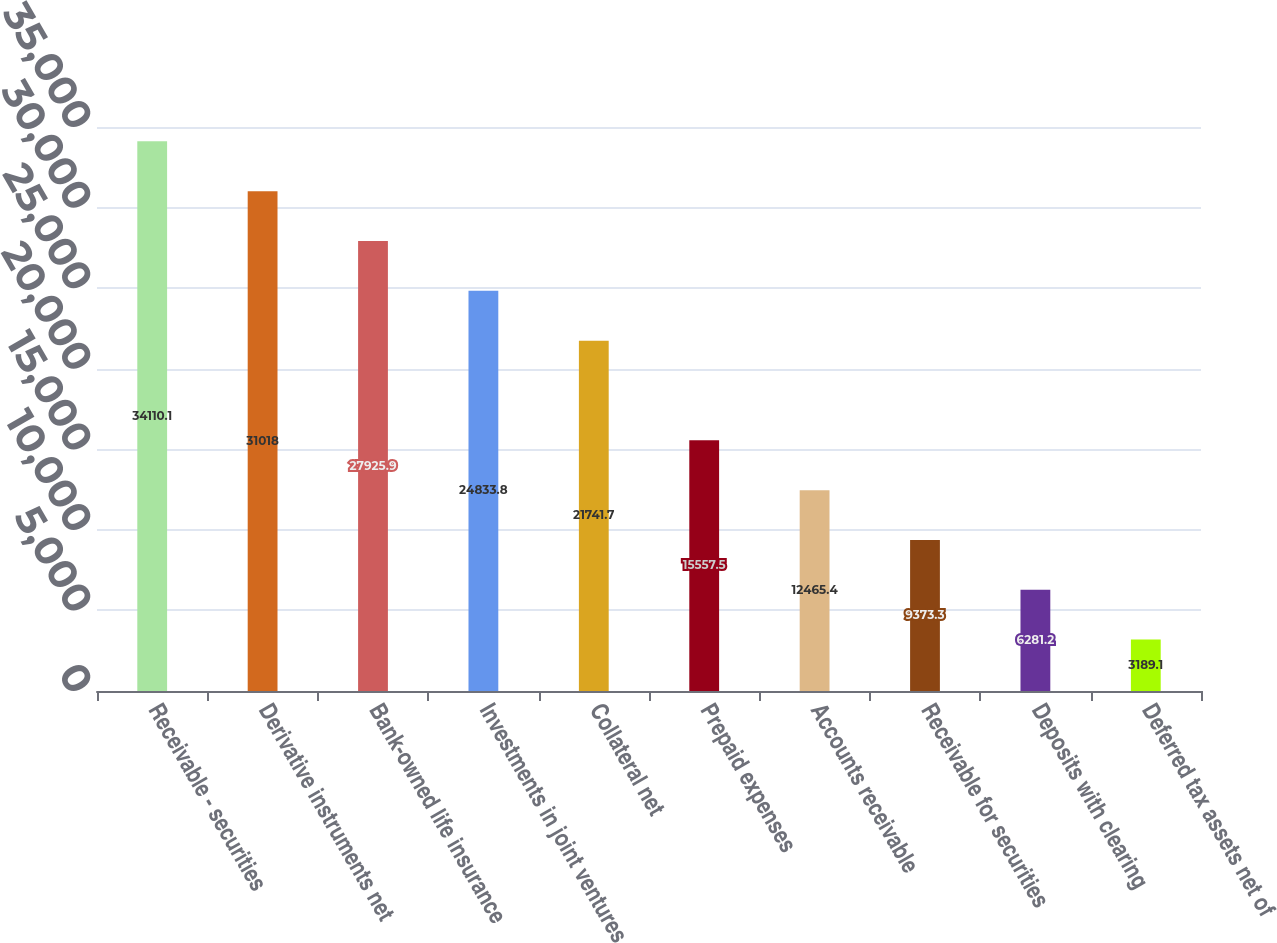<chart> <loc_0><loc_0><loc_500><loc_500><bar_chart><fcel>Receivable - securities<fcel>Derivative instruments net<fcel>Bank-owned life insurance<fcel>Investments in joint ventures<fcel>Collateral net<fcel>Prepaid expenses<fcel>Accounts receivable<fcel>Receivable for securities<fcel>Deposits with clearing<fcel>Deferred tax assets net of<nl><fcel>34110.1<fcel>31018<fcel>27925.9<fcel>24833.8<fcel>21741.7<fcel>15557.5<fcel>12465.4<fcel>9373.3<fcel>6281.2<fcel>3189.1<nl></chart> 